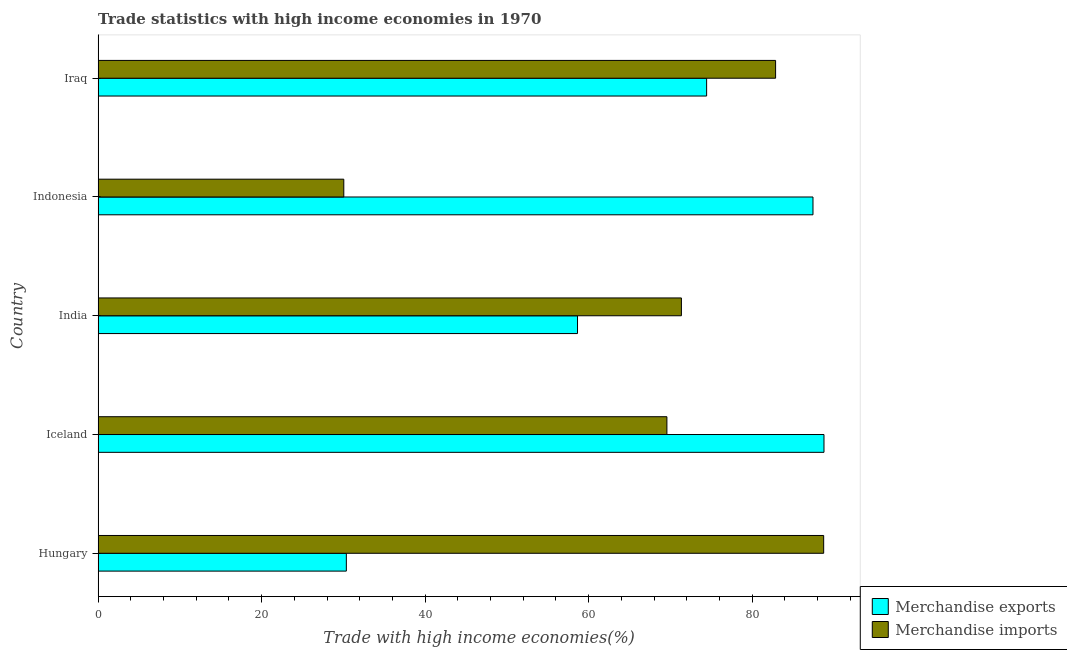How many different coloured bars are there?
Your response must be concise. 2. How many groups of bars are there?
Provide a succinct answer. 5. Are the number of bars per tick equal to the number of legend labels?
Your answer should be compact. Yes. What is the label of the 1st group of bars from the top?
Your response must be concise. Iraq. What is the merchandise imports in Iceland?
Offer a very short reply. 69.57. Across all countries, what is the maximum merchandise exports?
Provide a succinct answer. 88.78. Across all countries, what is the minimum merchandise imports?
Offer a very short reply. 30.05. In which country was the merchandise imports maximum?
Provide a short and direct response. Hungary. In which country was the merchandise imports minimum?
Provide a succinct answer. Indonesia. What is the total merchandise imports in the graph?
Offer a terse response. 342.58. What is the difference between the merchandise imports in India and that in Iraq?
Keep it short and to the point. -11.52. What is the difference between the merchandise imports in Indonesia and the merchandise exports in India?
Ensure brevity in your answer.  -28.59. What is the average merchandise imports per country?
Keep it short and to the point. 68.52. What is the difference between the merchandise exports and merchandise imports in Iceland?
Keep it short and to the point. 19.21. In how many countries, is the merchandise exports greater than 12 %?
Keep it short and to the point. 5. What is the ratio of the merchandise exports in Iceland to that in Iraq?
Offer a terse response. 1.19. Is the merchandise imports in Hungary less than that in Indonesia?
Your answer should be very brief. No. What is the difference between the highest and the second highest merchandise exports?
Make the answer very short. 1.34. What is the difference between the highest and the lowest merchandise imports?
Your answer should be very brief. 58.7. In how many countries, is the merchandise imports greater than the average merchandise imports taken over all countries?
Provide a short and direct response. 4. Is the sum of the merchandise exports in Hungary and India greater than the maximum merchandise imports across all countries?
Make the answer very short. Yes. What does the 2nd bar from the bottom in Indonesia represents?
Keep it short and to the point. Merchandise imports. How many bars are there?
Give a very brief answer. 10. How many countries are there in the graph?
Offer a terse response. 5. Does the graph contain grids?
Make the answer very short. No. Where does the legend appear in the graph?
Your response must be concise. Bottom right. How many legend labels are there?
Your answer should be compact. 2. What is the title of the graph?
Provide a succinct answer. Trade statistics with high income economies in 1970. What is the label or title of the X-axis?
Your answer should be compact. Trade with high income economies(%). What is the label or title of the Y-axis?
Offer a terse response. Country. What is the Trade with high income economies(%) in Merchandise exports in Hungary?
Make the answer very short. 30.36. What is the Trade with high income economies(%) in Merchandise imports in Hungary?
Keep it short and to the point. 88.75. What is the Trade with high income economies(%) of Merchandise exports in Iceland?
Keep it short and to the point. 88.78. What is the Trade with high income economies(%) of Merchandise imports in Iceland?
Your response must be concise. 69.57. What is the Trade with high income economies(%) of Merchandise exports in India?
Ensure brevity in your answer.  58.64. What is the Trade with high income economies(%) in Merchandise imports in India?
Provide a succinct answer. 71.35. What is the Trade with high income economies(%) of Merchandise exports in Indonesia?
Provide a short and direct response. 87.44. What is the Trade with high income economies(%) of Merchandise imports in Indonesia?
Provide a succinct answer. 30.05. What is the Trade with high income economies(%) in Merchandise exports in Iraq?
Your answer should be very brief. 74.43. What is the Trade with high income economies(%) of Merchandise imports in Iraq?
Your response must be concise. 82.87. Across all countries, what is the maximum Trade with high income economies(%) in Merchandise exports?
Offer a very short reply. 88.78. Across all countries, what is the maximum Trade with high income economies(%) in Merchandise imports?
Offer a terse response. 88.75. Across all countries, what is the minimum Trade with high income economies(%) in Merchandise exports?
Keep it short and to the point. 30.36. Across all countries, what is the minimum Trade with high income economies(%) of Merchandise imports?
Ensure brevity in your answer.  30.05. What is the total Trade with high income economies(%) of Merchandise exports in the graph?
Your answer should be very brief. 339.66. What is the total Trade with high income economies(%) in Merchandise imports in the graph?
Provide a short and direct response. 342.58. What is the difference between the Trade with high income economies(%) of Merchandise exports in Hungary and that in Iceland?
Ensure brevity in your answer.  -58.42. What is the difference between the Trade with high income economies(%) of Merchandise imports in Hungary and that in Iceland?
Provide a short and direct response. 19.18. What is the difference between the Trade with high income economies(%) of Merchandise exports in Hungary and that in India?
Offer a terse response. -28.28. What is the difference between the Trade with high income economies(%) of Merchandise imports in Hungary and that in India?
Keep it short and to the point. 17.4. What is the difference between the Trade with high income economies(%) of Merchandise exports in Hungary and that in Indonesia?
Your answer should be very brief. -57.08. What is the difference between the Trade with high income economies(%) of Merchandise imports in Hungary and that in Indonesia?
Give a very brief answer. 58.7. What is the difference between the Trade with high income economies(%) in Merchandise exports in Hungary and that in Iraq?
Provide a succinct answer. -44.07. What is the difference between the Trade with high income economies(%) in Merchandise imports in Hungary and that in Iraq?
Keep it short and to the point. 5.88. What is the difference between the Trade with high income economies(%) of Merchandise exports in Iceland and that in India?
Make the answer very short. 30.15. What is the difference between the Trade with high income economies(%) of Merchandise imports in Iceland and that in India?
Provide a short and direct response. -1.77. What is the difference between the Trade with high income economies(%) in Merchandise exports in Iceland and that in Indonesia?
Provide a succinct answer. 1.34. What is the difference between the Trade with high income economies(%) of Merchandise imports in Iceland and that in Indonesia?
Offer a very short reply. 39.52. What is the difference between the Trade with high income economies(%) of Merchandise exports in Iceland and that in Iraq?
Keep it short and to the point. 14.36. What is the difference between the Trade with high income economies(%) in Merchandise imports in Iceland and that in Iraq?
Your answer should be very brief. -13.29. What is the difference between the Trade with high income economies(%) in Merchandise exports in India and that in Indonesia?
Your answer should be compact. -28.8. What is the difference between the Trade with high income economies(%) of Merchandise imports in India and that in Indonesia?
Provide a succinct answer. 41.29. What is the difference between the Trade with high income economies(%) of Merchandise exports in India and that in Iraq?
Provide a succinct answer. -15.79. What is the difference between the Trade with high income economies(%) in Merchandise imports in India and that in Iraq?
Offer a very short reply. -11.52. What is the difference between the Trade with high income economies(%) in Merchandise exports in Indonesia and that in Iraq?
Offer a very short reply. 13.01. What is the difference between the Trade with high income economies(%) of Merchandise imports in Indonesia and that in Iraq?
Your response must be concise. -52.82. What is the difference between the Trade with high income economies(%) in Merchandise exports in Hungary and the Trade with high income economies(%) in Merchandise imports in Iceland?
Provide a short and direct response. -39.21. What is the difference between the Trade with high income economies(%) in Merchandise exports in Hungary and the Trade with high income economies(%) in Merchandise imports in India?
Your response must be concise. -40.98. What is the difference between the Trade with high income economies(%) in Merchandise exports in Hungary and the Trade with high income economies(%) in Merchandise imports in Indonesia?
Offer a terse response. 0.31. What is the difference between the Trade with high income economies(%) in Merchandise exports in Hungary and the Trade with high income economies(%) in Merchandise imports in Iraq?
Your answer should be very brief. -52.51. What is the difference between the Trade with high income economies(%) of Merchandise exports in Iceland and the Trade with high income economies(%) of Merchandise imports in India?
Your answer should be very brief. 17.44. What is the difference between the Trade with high income economies(%) in Merchandise exports in Iceland and the Trade with high income economies(%) in Merchandise imports in Indonesia?
Keep it short and to the point. 58.73. What is the difference between the Trade with high income economies(%) in Merchandise exports in Iceland and the Trade with high income economies(%) in Merchandise imports in Iraq?
Provide a succinct answer. 5.92. What is the difference between the Trade with high income economies(%) in Merchandise exports in India and the Trade with high income economies(%) in Merchandise imports in Indonesia?
Provide a succinct answer. 28.59. What is the difference between the Trade with high income economies(%) of Merchandise exports in India and the Trade with high income economies(%) of Merchandise imports in Iraq?
Ensure brevity in your answer.  -24.23. What is the difference between the Trade with high income economies(%) of Merchandise exports in Indonesia and the Trade with high income economies(%) of Merchandise imports in Iraq?
Offer a very short reply. 4.57. What is the average Trade with high income economies(%) in Merchandise exports per country?
Keep it short and to the point. 67.93. What is the average Trade with high income economies(%) of Merchandise imports per country?
Your answer should be compact. 68.52. What is the difference between the Trade with high income economies(%) of Merchandise exports and Trade with high income economies(%) of Merchandise imports in Hungary?
Your answer should be very brief. -58.39. What is the difference between the Trade with high income economies(%) of Merchandise exports and Trade with high income economies(%) of Merchandise imports in Iceland?
Give a very brief answer. 19.21. What is the difference between the Trade with high income economies(%) of Merchandise exports and Trade with high income economies(%) of Merchandise imports in India?
Provide a short and direct response. -12.71. What is the difference between the Trade with high income economies(%) of Merchandise exports and Trade with high income economies(%) of Merchandise imports in Indonesia?
Your answer should be very brief. 57.39. What is the difference between the Trade with high income economies(%) of Merchandise exports and Trade with high income economies(%) of Merchandise imports in Iraq?
Offer a very short reply. -8.44. What is the ratio of the Trade with high income economies(%) in Merchandise exports in Hungary to that in Iceland?
Make the answer very short. 0.34. What is the ratio of the Trade with high income economies(%) in Merchandise imports in Hungary to that in Iceland?
Make the answer very short. 1.28. What is the ratio of the Trade with high income economies(%) of Merchandise exports in Hungary to that in India?
Your answer should be compact. 0.52. What is the ratio of the Trade with high income economies(%) in Merchandise imports in Hungary to that in India?
Give a very brief answer. 1.24. What is the ratio of the Trade with high income economies(%) in Merchandise exports in Hungary to that in Indonesia?
Offer a very short reply. 0.35. What is the ratio of the Trade with high income economies(%) of Merchandise imports in Hungary to that in Indonesia?
Your response must be concise. 2.95. What is the ratio of the Trade with high income economies(%) in Merchandise exports in Hungary to that in Iraq?
Your answer should be very brief. 0.41. What is the ratio of the Trade with high income economies(%) in Merchandise imports in Hungary to that in Iraq?
Offer a very short reply. 1.07. What is the ratio of the Trade with high income economies(%) of Merchandise exports in Iceland to that in India?
Keep it short and to the point. 1.51. What is the ratio of the Trade with high income economies(%) of Merchandise imports in Iceland to that in India?
Provide a succinct answer. 0.98. What is the ratio of the Trade with high income economies(%) of Merchandise exports in Iceland to that in Indonesia?
Make the answer very short. 1.02. What is the ratio of the Trade with high income economies(%) in Merchandise imports in Iceland to that in Indonesia?
Your response must be concise. 2.32. What is the ratio of the Trade with high income economies(%) of Merchandise exports in Iceland to that in Iraq?
Your response must be concise. 1.19. What is the ratio of the Trade with high income economies(%) of Merchandise imports in Iceland to that in Iraq?
Offer a terse response. 0.84. What is the ratio of the Trade with high income economies(%) in Merchandise exports in India to that in Indonesia?
Offer a terse response. 0.67. What is the ratio of the Trade with high income economies(%) in Merchandise imports in India to that in Indonesia?
Keep it short and to the point. 2.37. What is the ratio of the Trade with high income economies(%) of Merchandise exports in India to that in Iraq?
Your answer should be compact. 0.79. What is the ratio of the Trade with high income economies(%) of Merchandise imports in India to that in Iraq?
Ensure brevity in your answer.  0.86. What is the ratio of the Trade with high income economies(%) in Merchandise exports in Indonesia to that in Iraq?
Offer a very short reply. 1.17. What is the ratio of the Trade with high income economies(%) in Merchandise imports in Indonesia to that in Iraq?
Keep it short and to the point. 0.36. What is the difference between the highest and the second highest Trade with high income economies(%) of Merchandise exports?
Make the answer very short. 1.34. What is the difference between the highest and the second highest Trade with high income economies(%) of Merchandise imports?
Give a very brief answer. 5.88. What is the difference between the highest and the lowest Trade with high income economies(%) in Merchandise exports?
Your answer should be very brief. 58.42. What is the difference between the highest and the lowest Trade with high income economies(%) in Merchandise imports?
Your response must be concise. 58.7. 